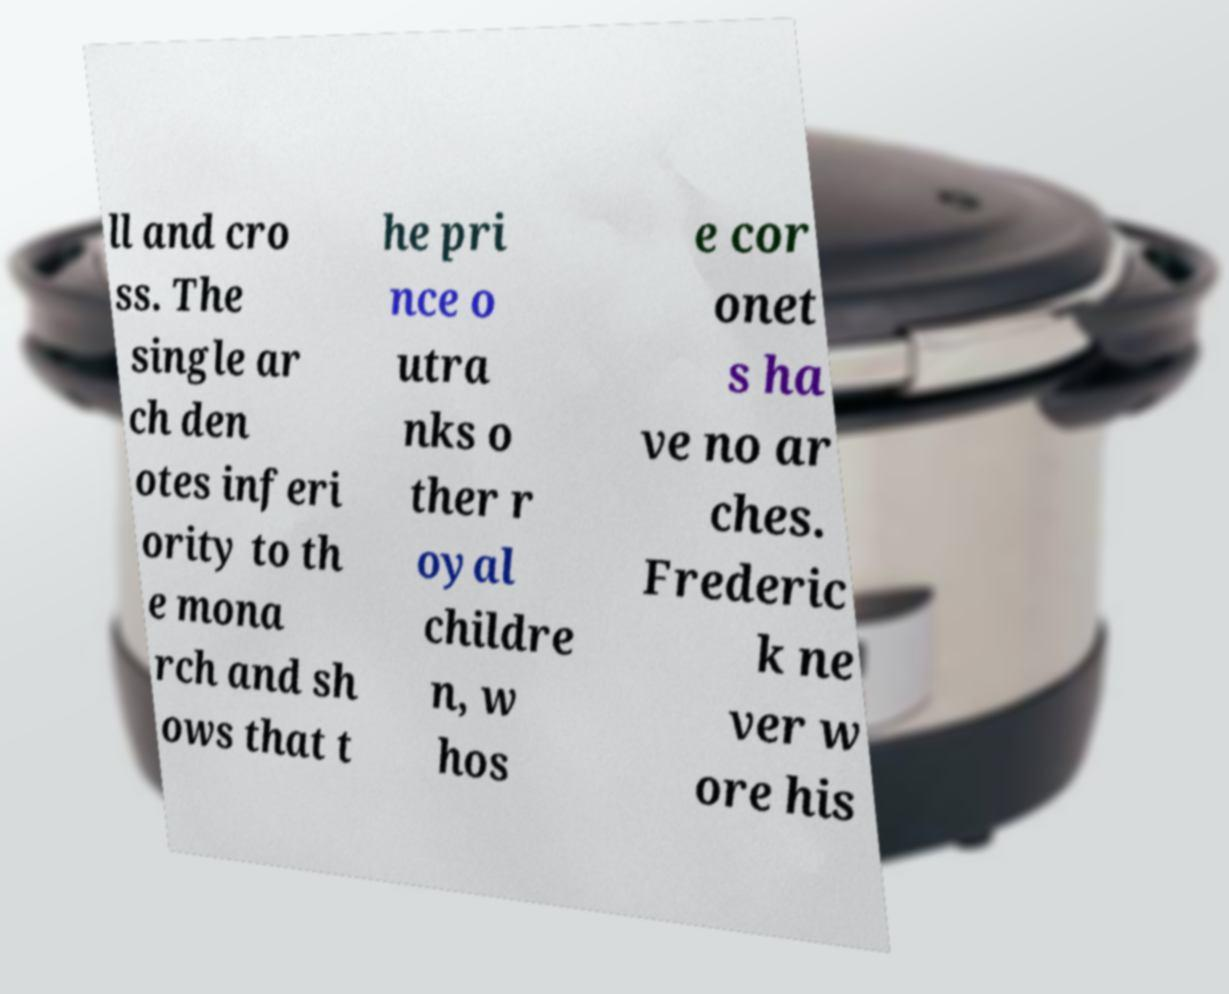I need the written content from this picture converted into text. Can you do that? ll and cro ss. The single ar ch den otes inferi ority to th e mona rch and sh ows that t he pri nce o utra nks o ther r oyal childre n, w hos e cor onet s ha ve no ar ches. Frederic k ne ver w ore his 